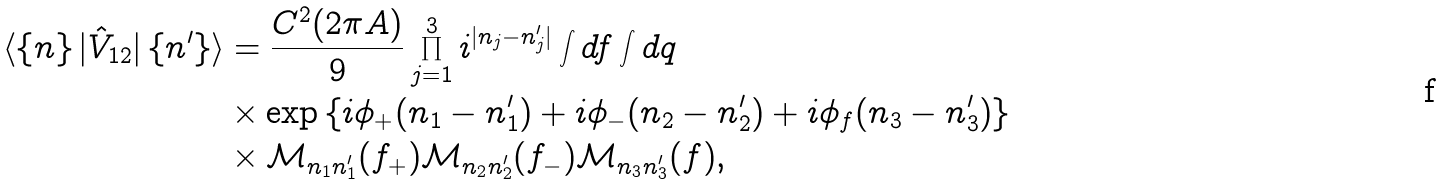Convert formula to latex. <formula><loc_0><loc_0><loc_500><loc_500>\langle \left \{ n \right \} | \hat { V } _ { 1 2 } | \left \{ n ^ { \prime } \right \} \rangle & = \frac { C ^ { 2 } ( 2 \pi A ) } { 9 } \prod _ { j = 1 } ^ { 3 } i ^ { | n _ { j } - n ^ { \prime } _ { j } | } \int d f \int d q \\ & \times \exp \left \{ i \phi _ { + } ( n _ { 1 } - n _ { 1 } ^ { \prime } ) + i \phi _ { - } ( n _ { 2 } - n _ { 2 } ^ { \prime } ) + i \phi _ { f } ( n _ { 3 } - n _ { 3 } ^ { \prime } ) \right \} \\ & \times \mathcal { M } _ { n _ { 1 } n ^ { \prime } _ { 1 } } ( f _ { + } ) \mathcal { M } _ { n _ { 2 } n ^ { \prime } _ { 2 } } ( f _ { - } ) \mathcal { M } _ { n _ { 3 } n ^ { \prime } _ { 3 } } ( f ) ,</formula> 